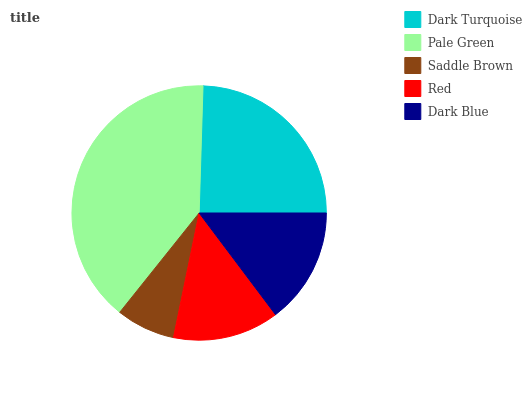Is Saddle Brown the minimum?
Answer yes or no. Yes. Is Pale Green the maximum?
Answer yes or no. Yes. Is Pale Green the minimum?
Answer yes or no. No. Is Saddle Brown the maximum?
Answer yes or no. No. Is Pale Green greater than Saddle Brown?
Answer yes or no. Yes. Is Saddle Brown less than Pale Green?
Answer yes or no. Yes. Is Saddle Brown greater than Pale Green?
Answer yes or no. No. Is Pale Green less than Saddle Brown?
Answer yes or no. No. Is Dark Blue the high median?
Answer yes or no. Yes. Is Dark Blue the low median?
Answer yes or no. Yes. Is Dark Turquoise the high median?
Answer yes or no. No. Is Dark Turquoise the low median?
Answer yes or no. No. 